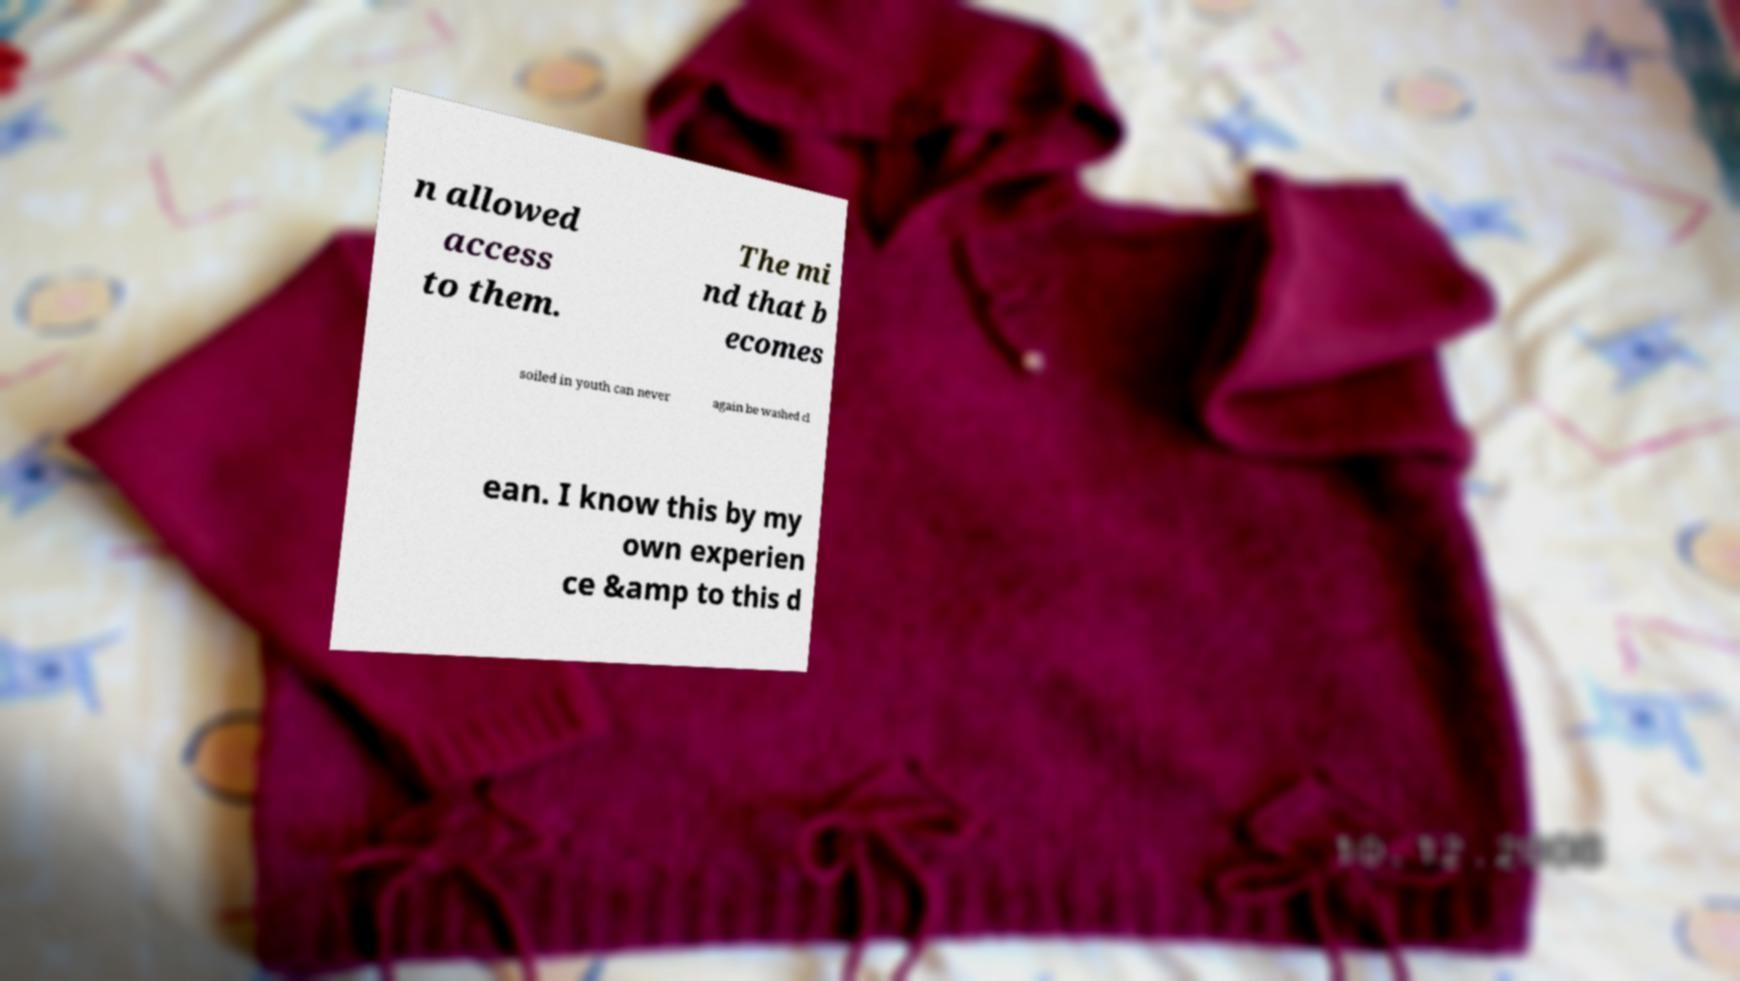Can you accurately transcribe the text from the provided image for me? n allowed access to them. The mi nd that b ecomes soiled in youth can never again be washed cl ean. I know this by my own experien ce &amp to this d 